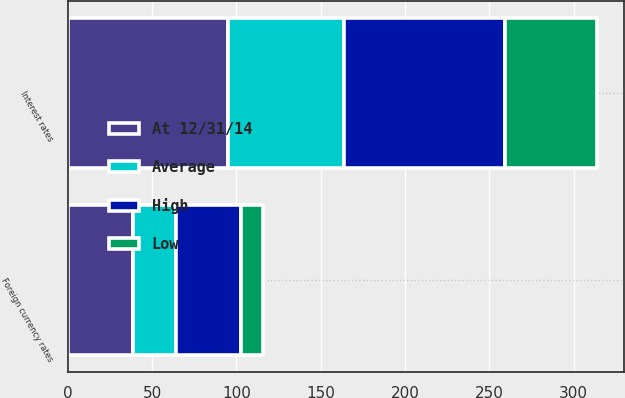Convert chart. <chart><loc_0><loc_0><loc_500><loc_500><stacked_bar_chart><ecel><fcel>Foreign currency rates<fcel>Interest rates<nl><fcel>At 12/31/14<fcel>39<fcel>95<nl><fcel>Average<fcel>25<fcel>69<nl><fcel>High<fcel>39<fcel>95<nl><fcel>Low<fcel>13<fcel>55<nl></chart> 